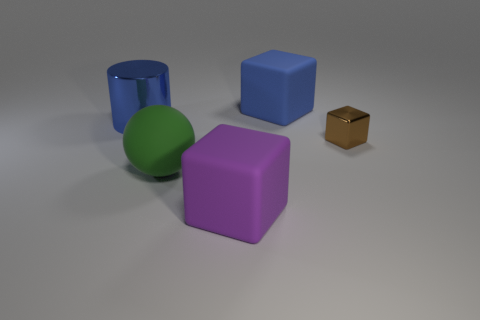The rubber object that is the same color as the large shiny cylinder is what size?
Your response must be concise. Large. Is the shape of the blue matte thing the same as the tiny brown object?
Offer a terse response. Yes. What is the size of the shiny thing that is on the right side of the rubber object behind the green sphere?
Ensure brevity in your answer.  Small. There is another small thing that is the same shape as the purple thing; what color is it?
Give a very brief answer. Brown. How many big objects are the same color as the big cylinder?
Your response must be concise. 1. What size is the brown shiny object?
Your answer should be compact. Small. Does the blue block have the same size as the purple matte block?
Make the answer very short. Yes. What is the color of the large object that is both behind the rubber sphere and left of the big blue rubber cube?
Offer a very short reply. Blue. What number of large blocks are made of the same material as the green ball?
Keep it short and to the point. 2. What number of matte spheres are there?
Your answer should be very brief. 1. 